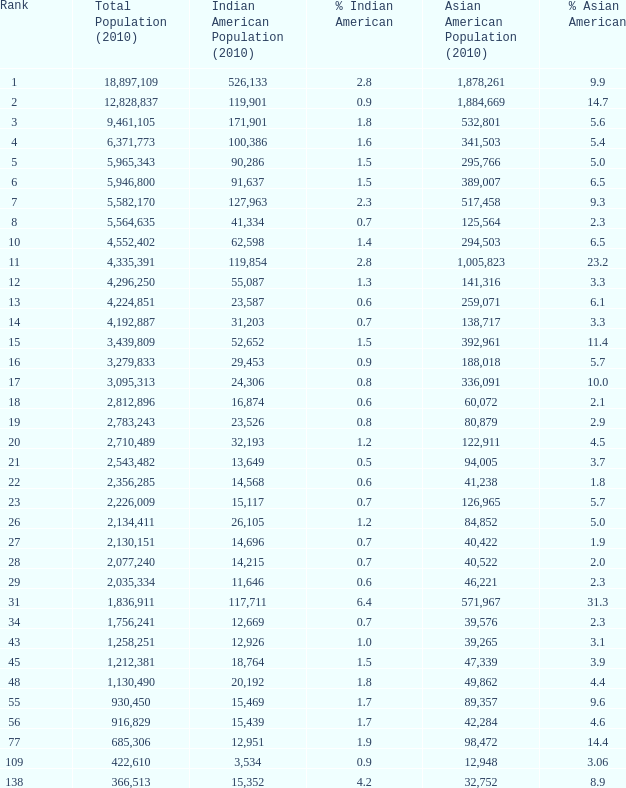What is the aggregate population when the asian american population is less than 60,072, the indian american population is more than 14,696, and it constitutes 366513.0. 